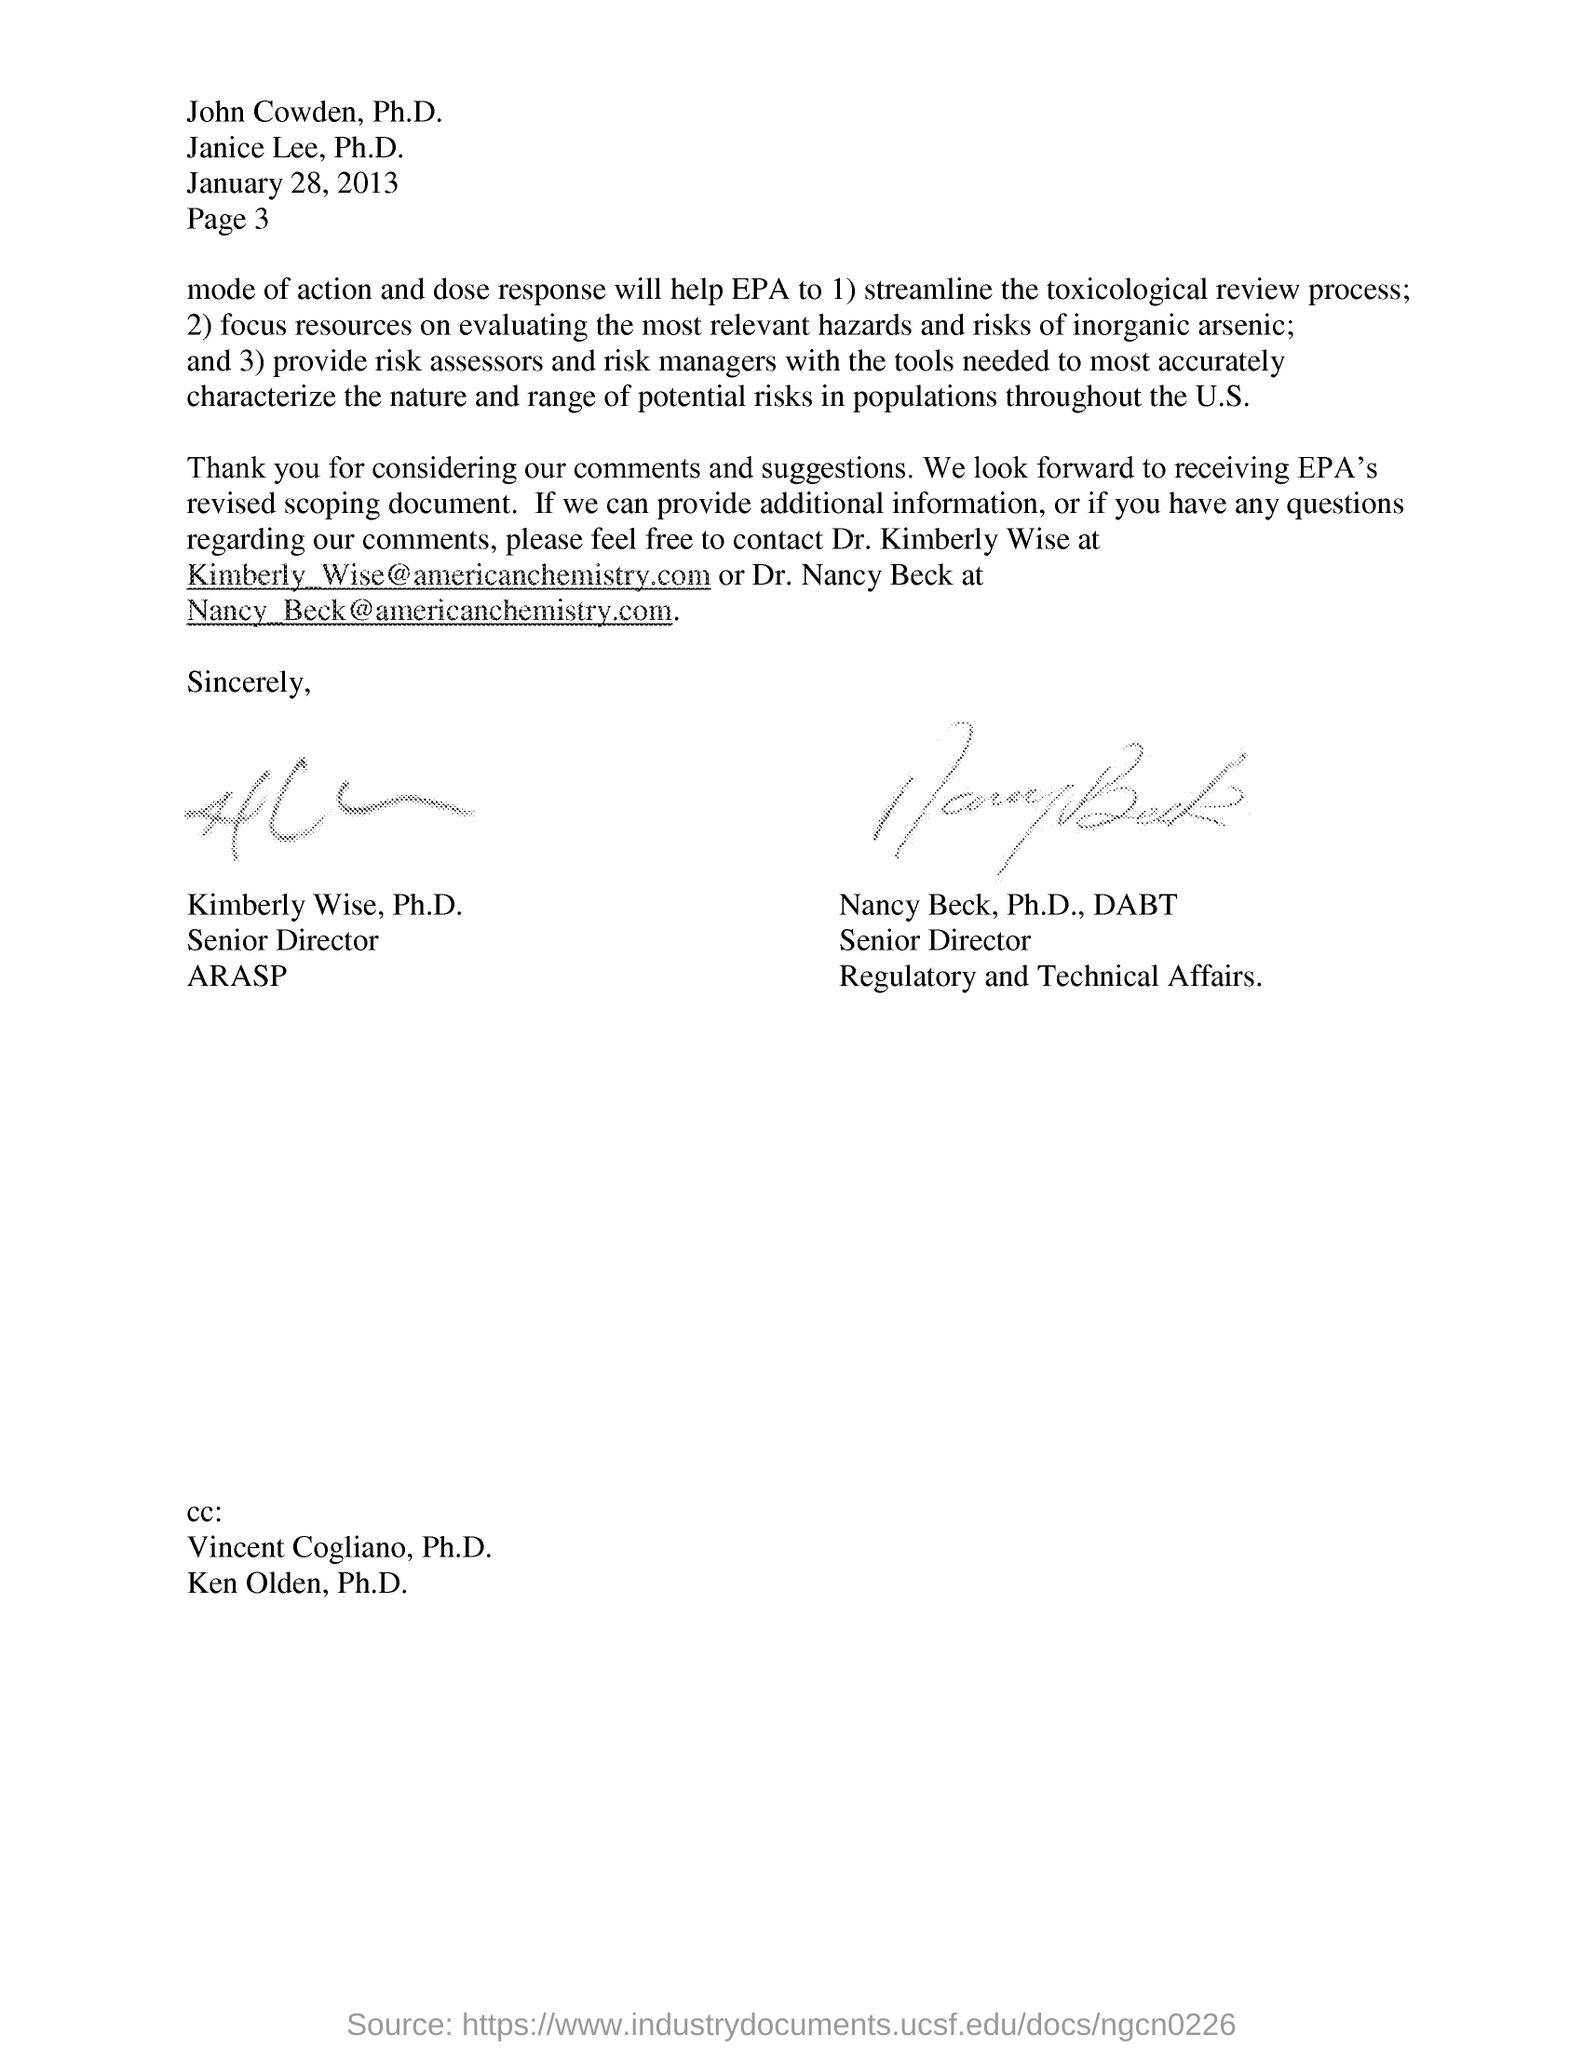Identify some key points in this picture. The email ID of Dr. Kimberly Wise is [kimberly\_wise@americanchemistry.com](mailto:kimberly_wise@americanchemistry.com). The person referred to in this letter as "senior director for ARASP" is Kimberly Wise. Vincent Cogliano's name should be mentioned in the CC. 